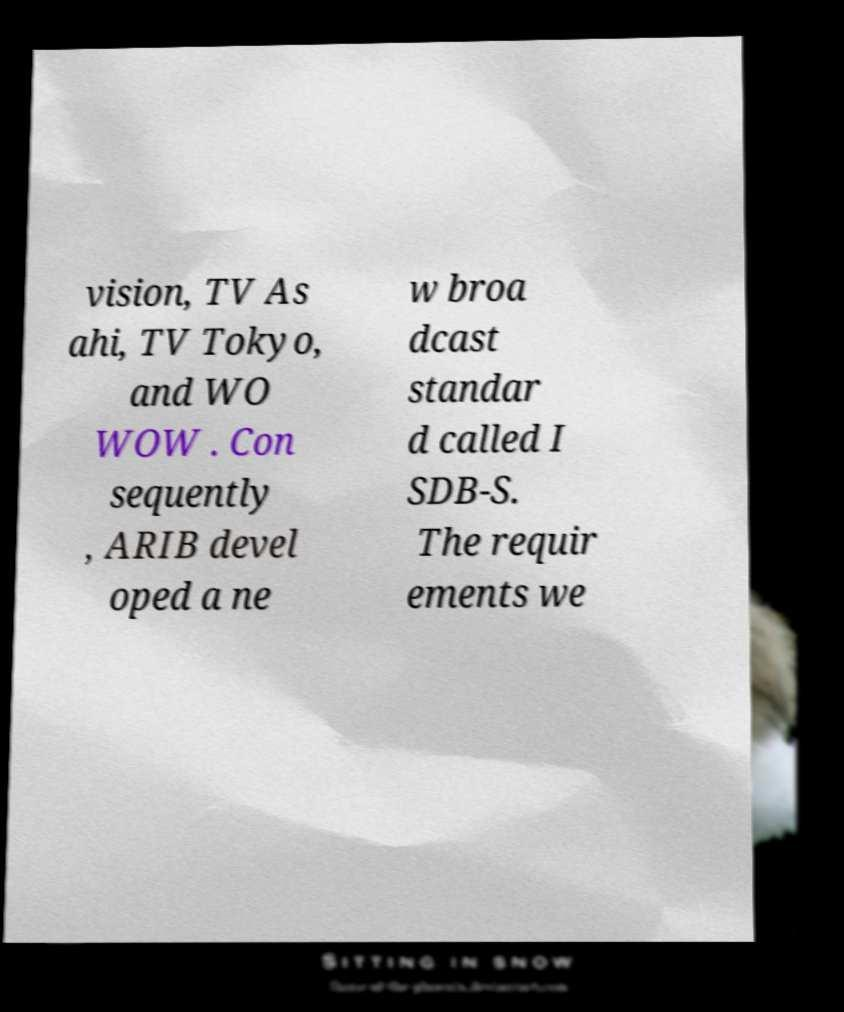What messages or text are displayed in this image? I need them in a readable, typed format. vision, TV As ahi, TV Tokyo, and WO WOW . Con sequently , ARIB devel oped a ne w broa dcast standar d called I SDB-S. The requir ements we 